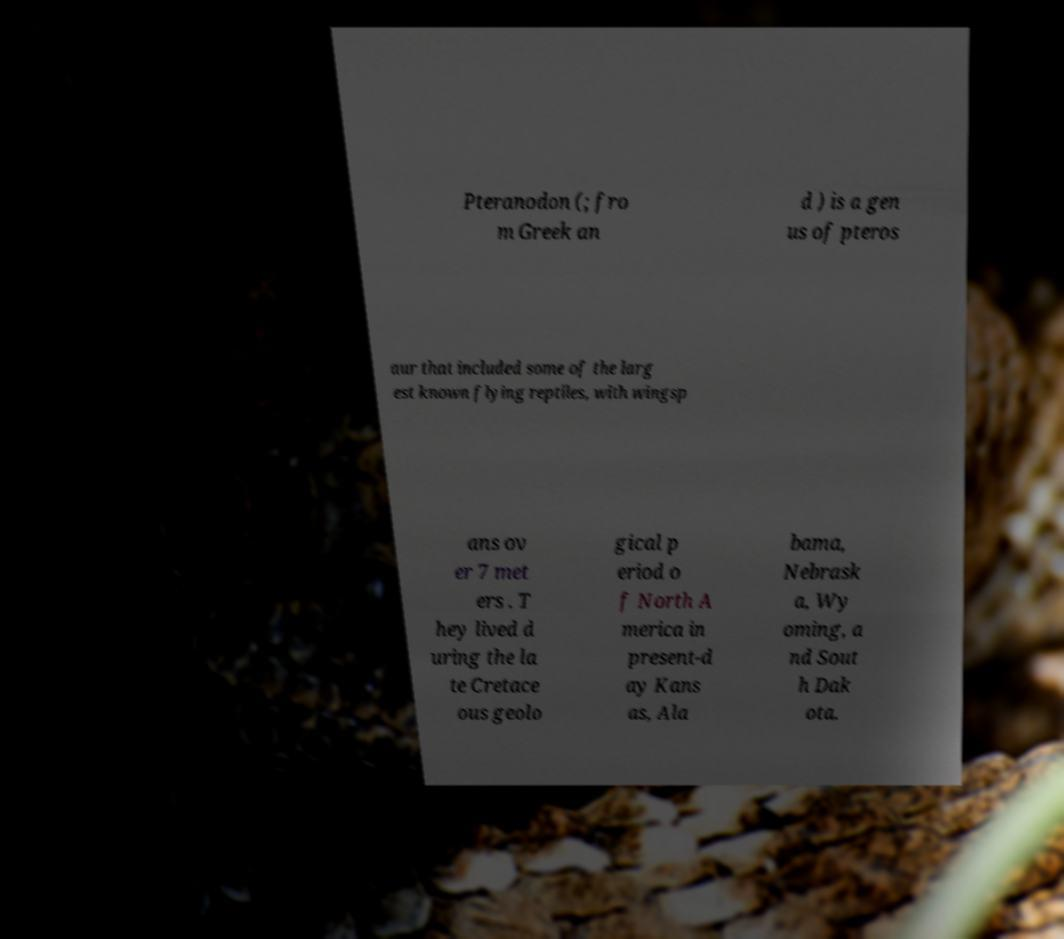There's text embedded in this image that I need extracted. Can you transcribe it verbatim? Pteranodon (; fro m Greek an d ) is a gen us of pteros aur that included some of the larg est known flying reptiles, with wingsp ans ov er 7 met ers . T hey lived d uring the la te Cretace ous geolo gical p eriod o f North A merica in present-d ay Kans as, Ala bama, Nebrask a, Wy oming, a nd Sout h Dak ota. 